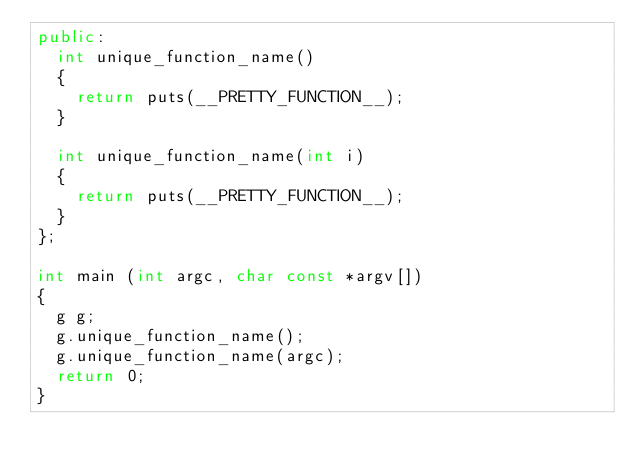Convert code to text. <code><loc_0><loc_0><loc_500><loc_500><_C++_>public:
  int unique_function_name()
  {
    return puts(__PRETTY_FUNCTION__); 
  }
  
  int unique_function_name(int i)
  {
    return puts(__PRETTY_FUNCTION__); 
  }
};

int main (int argc, char const *argv[])
{
  g g;
  g.unique_function_name();
  g.unique_function_name(argc);
  return 0;
}</code> 